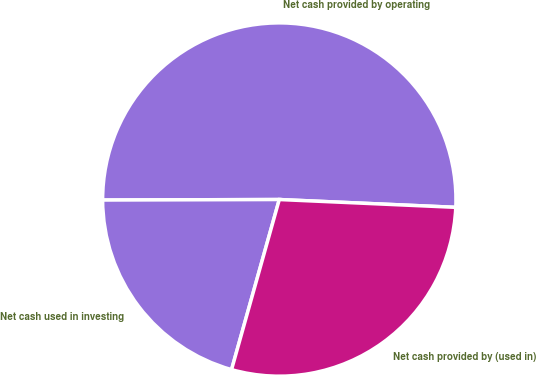Convert chart. <chart><loc_0><loc_0><loc_500><loc_500><pie_chart><fcel>Net cash provided by operating<fcel>Net cash used in investing<fcel>Net cash provided by (used in)<nl><fcel>50.75%<fcel>20.6%<fcel>28.65%<nl></chart> 